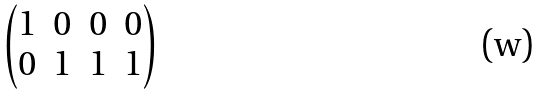Convert formula to latex. <formula><loc_0><loc_0><loc_500><loc_500>\begin{pmatrix} 1 & 0 & 0 & 0 \\ 0 & 1 & 1 & 1 \end{pmatrix}</formula> 